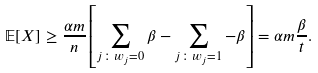Convert formula to latex. <formula><loc_0><loc_0><loc_500><loc_500>\mathbb { E } [ X ] & \geq \frac { \alpha m } { n } \left [ \sum _ { j \colon w _ { j } = 0 } \beta - \sum _ { j \colon w _ { j } = 1 } - \beta \right ] = \alpha m \frac { \beta } { t } .</formula> 